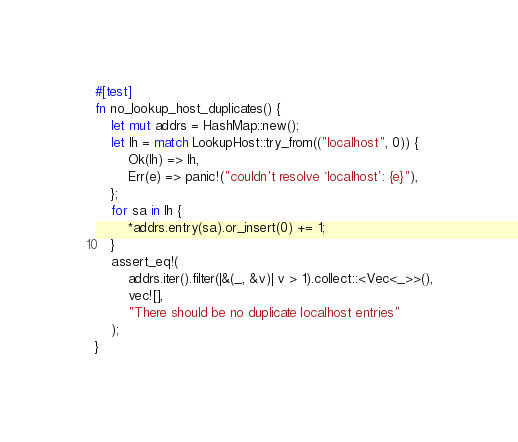<code> <loc_0><loc_0><loc_500><loc_500><_Rust_>#[test]
fn no_lookup_host_duplicates() {
    let mut addrs = HashMap::new();
    let lh = match LookupHost::try_from(("localhost", 0)) {
        Ok(lh) => lh,
        Err(e) => panic!("couldn't resolve `localhost': {e}"),
    };
    for sa in lh {
        *addrs.entry(sa).or_insert(0) += 1;
    }
    assert_eq!(
        addrs.iter().filter(|&(_, &v)| v > 1).collect::<Vec<_>>(),
        vec![],
        "There should be no duplicate localhost entries"
    );
}
</code> 